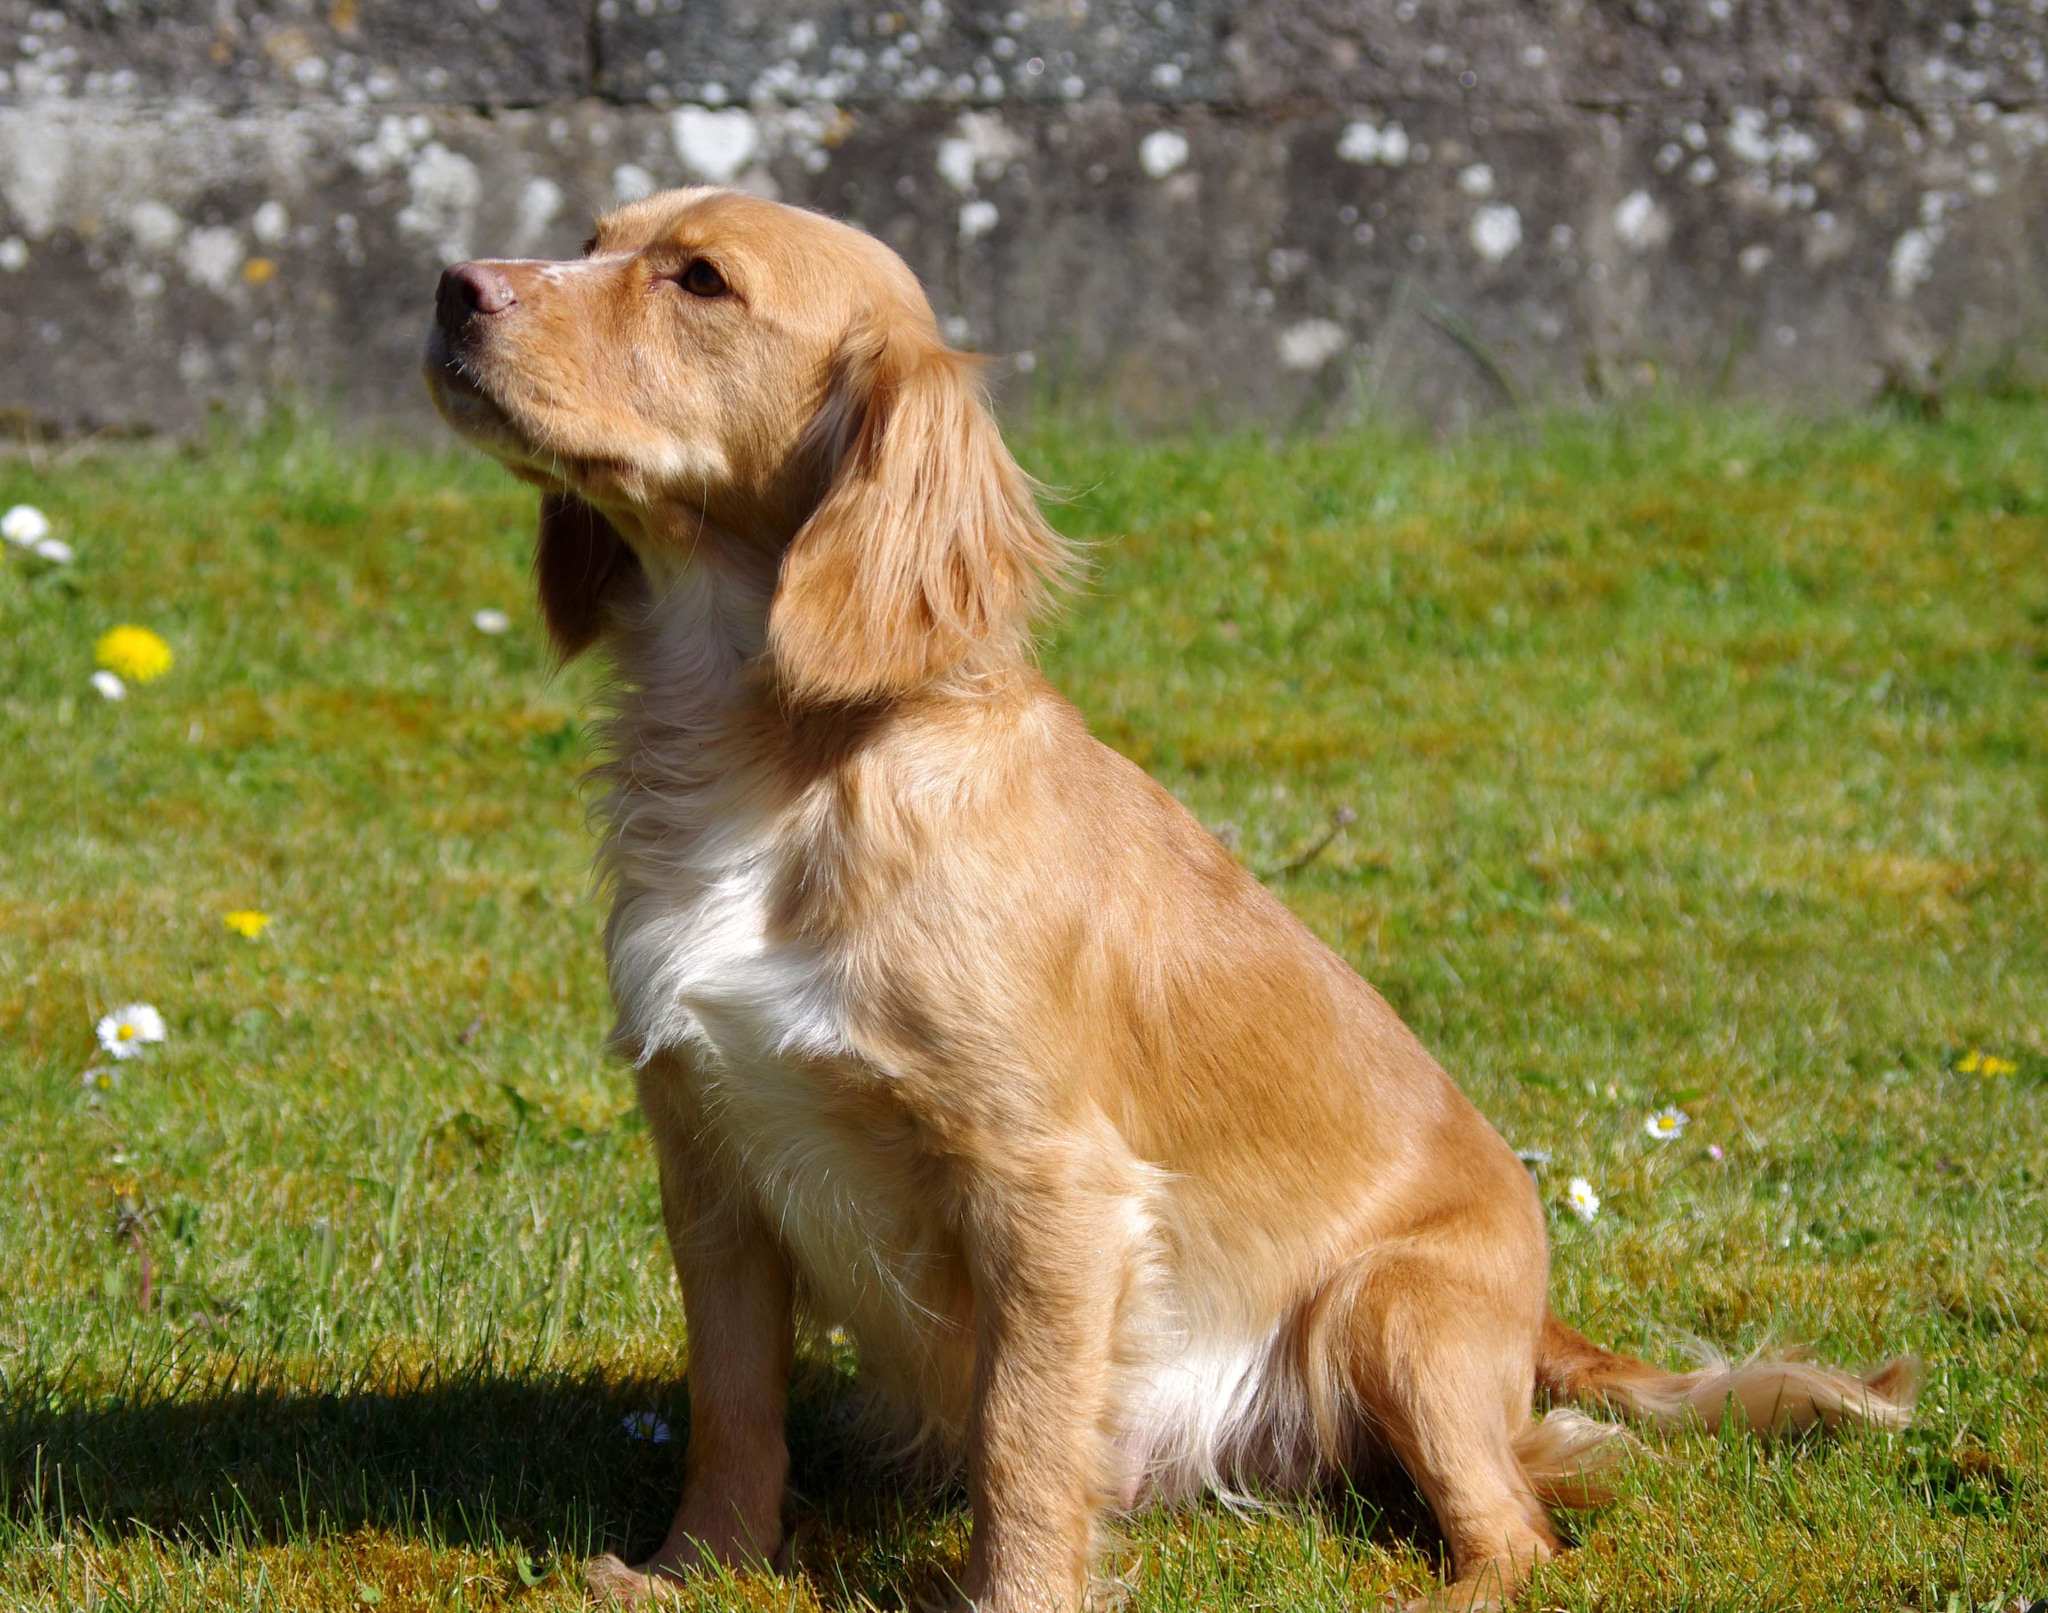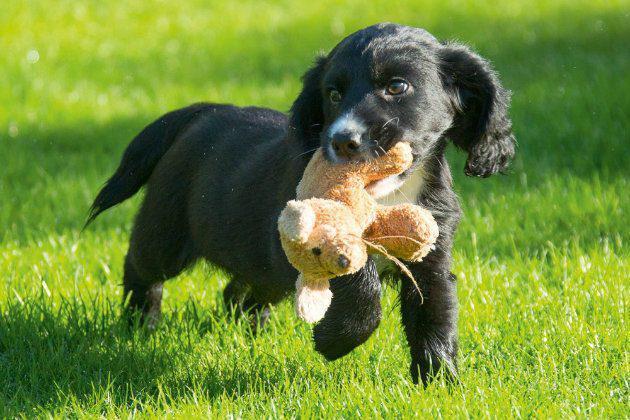The first image is the image on the left, the second image is the image on the right. Examine the images to the left and right. Is the description "One image shows a mostly gold dog sitting upright, and the other shows a dog moving forward over the grass." accurate? Answer yes or no. Yes. The first image is the image on the left, the second image is the image on the right. Analyze the images presented: Is the assertion "The dog in the image on the left is sitting on the grass." valid? Answer yes or no. Yes. 